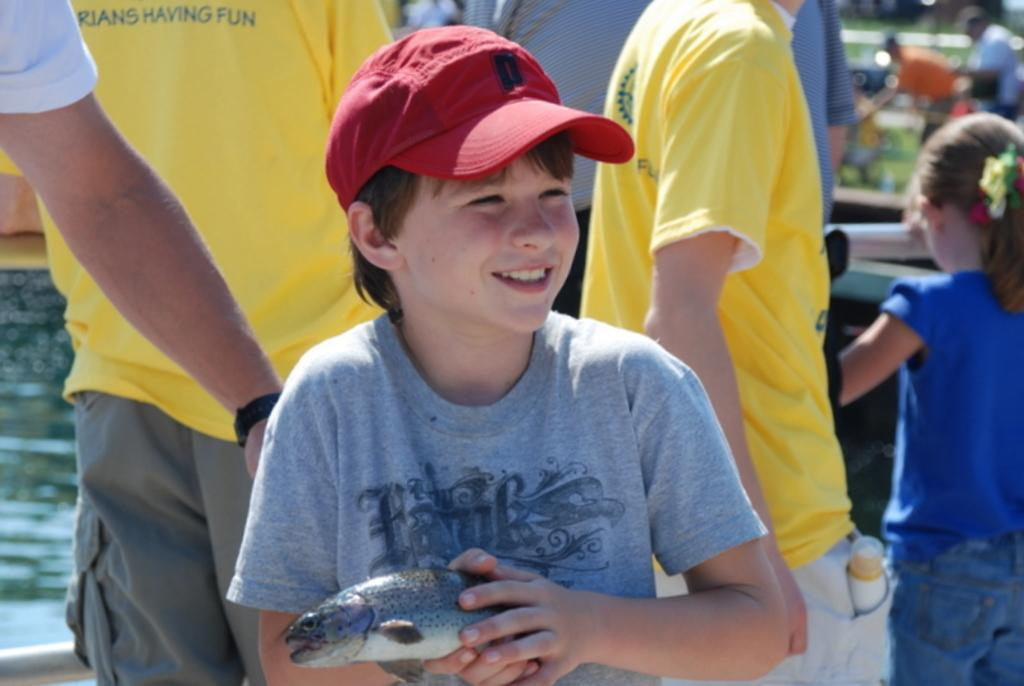Who is the main subject in the image? There is a boy in the image. What is the boy wearing on his head? The boy is wearing a red cap. What color is the boy's t-shirt? The boy is wearing a grey t-shirt. What is the boy holding in his hand? The boy is holding a fish in his hand. Can you describe the background of the image? There is a group of people in the background of the image. What is visible in the image besides the boy and the group of people? There is water visible in the image. What type of machine is the boy using to catch the fish in the image? There is no machine present in the image; the boy is holding a fish in his hand. What season is depicted in the image? The provided facts do not mention any seasonal details, so it cannot be determined from the image. 